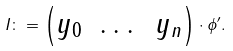<formula> <loc_0><loc_0><loc_500><loc_500>I \colon = \begin{pmatrix} y _ { 0 } & \dots & y _ { n } \end{pmatrix} \cdot \phi ^ { \prime } .</formula> 